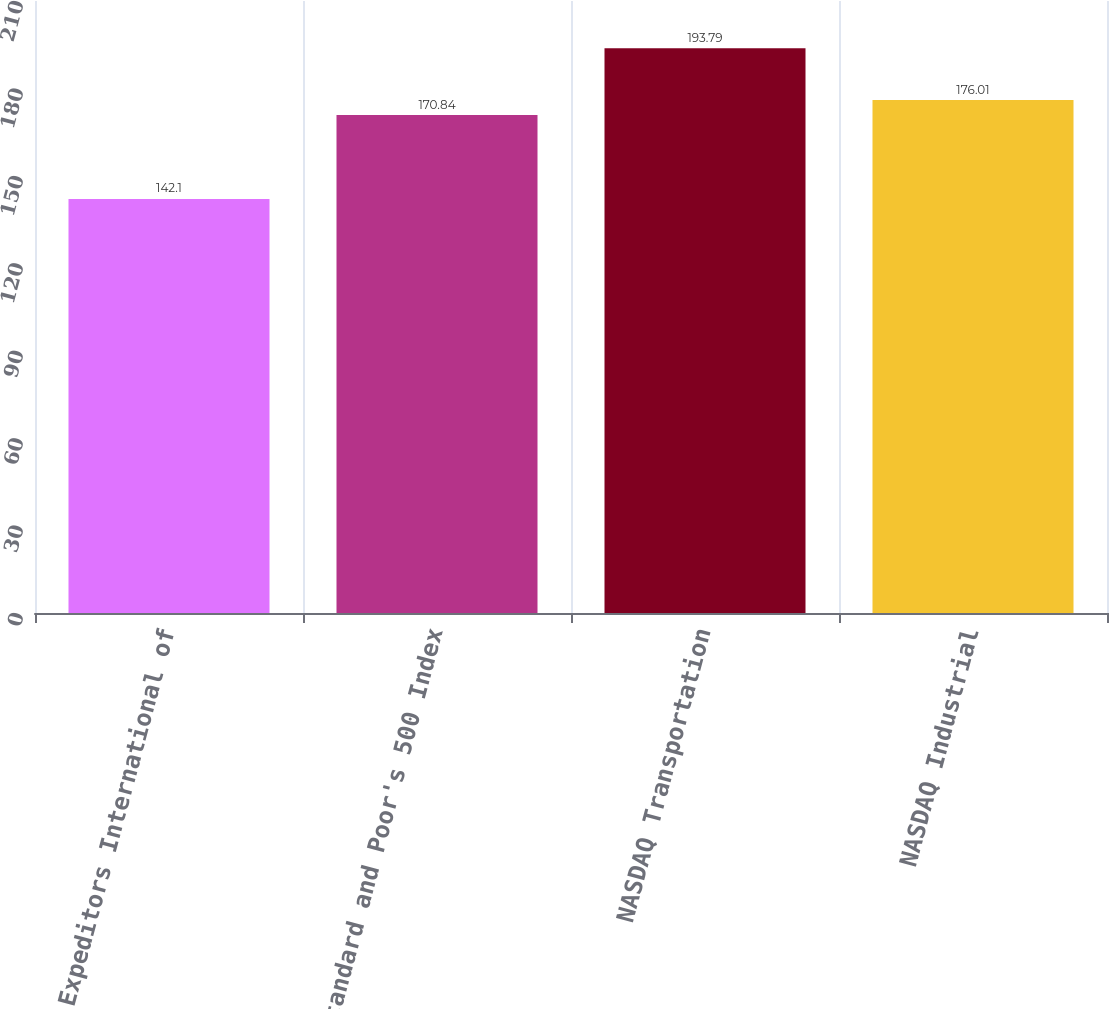Convert chart to OTSL. <chart><loc_0><loc_0><loc_500><loc_500><bar_chart><fcel>Expeditors International of<fcel>Standard and Poor's 500 Index<fcel>NASDAQ Transportation<fcel>NASDAQ Industrial<nl><fcel>142.1<fcel>170.84<fcel>193.79<fcel>176.01<nl></chart> 